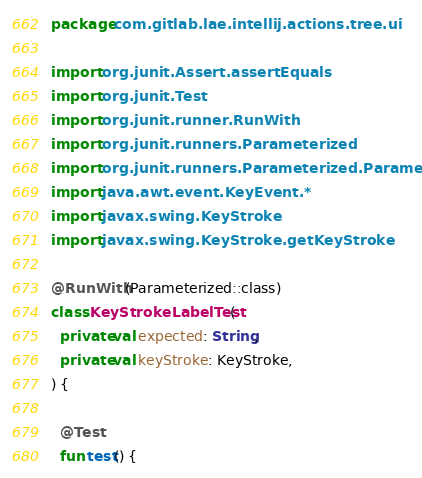<code> <loc_0><loc_0><loc_500><loc_500><_Kotlin_>package com.gitlab.lae.intellij.actions.tree.ui

import org.junit.Assert.assertEquals
import org.junit.Test
import org.junit.runner.RunWith
import org.junit.runners.Parameterized
import org.junit.runners.Parameterized.Parameters
import java.awt.event.KeyEvent.*
import javax.swing.KeyStroke
import javax.swing.KeyStroke.getKeyStroke

@RunWith(Parameterized::class)
class KeyStrokeLabelTest(
  private val expected: String,
  private val keyStroke: KeyStroke,
) {

  @Test
  fun test() {</code> 